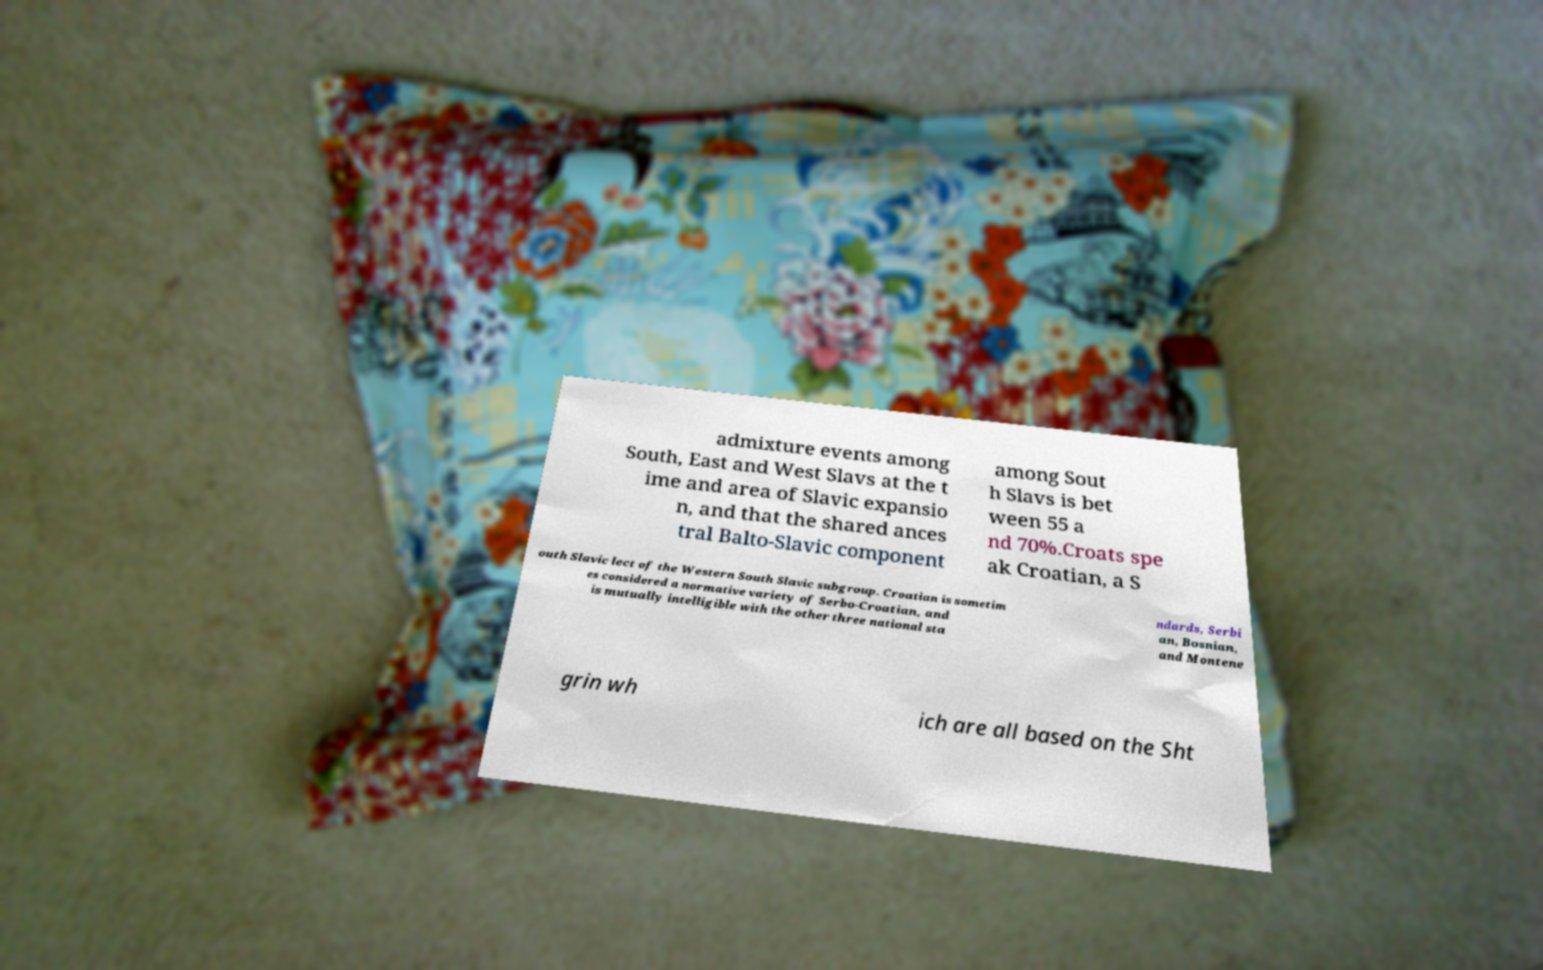I need the written content from this picture converted into text. Can you do that? admixture events among South, East and West Slavs at the t ime and area of Slavic expansio n, and that the shared ances tral Balto-Slavic component among Sout h Slavs is bet ween 55 a nd 70%.Croats spe ak Croatian, a S outh Slavic lect of the Western South Slavic subgroup. Croatian is sometim es considered a normative variety of Serbo-Croatian, and is mutually intelligible with the other three national sta ndards, Serbi an, Bosnian, and Montene grin wh ich are all based on the Sht 